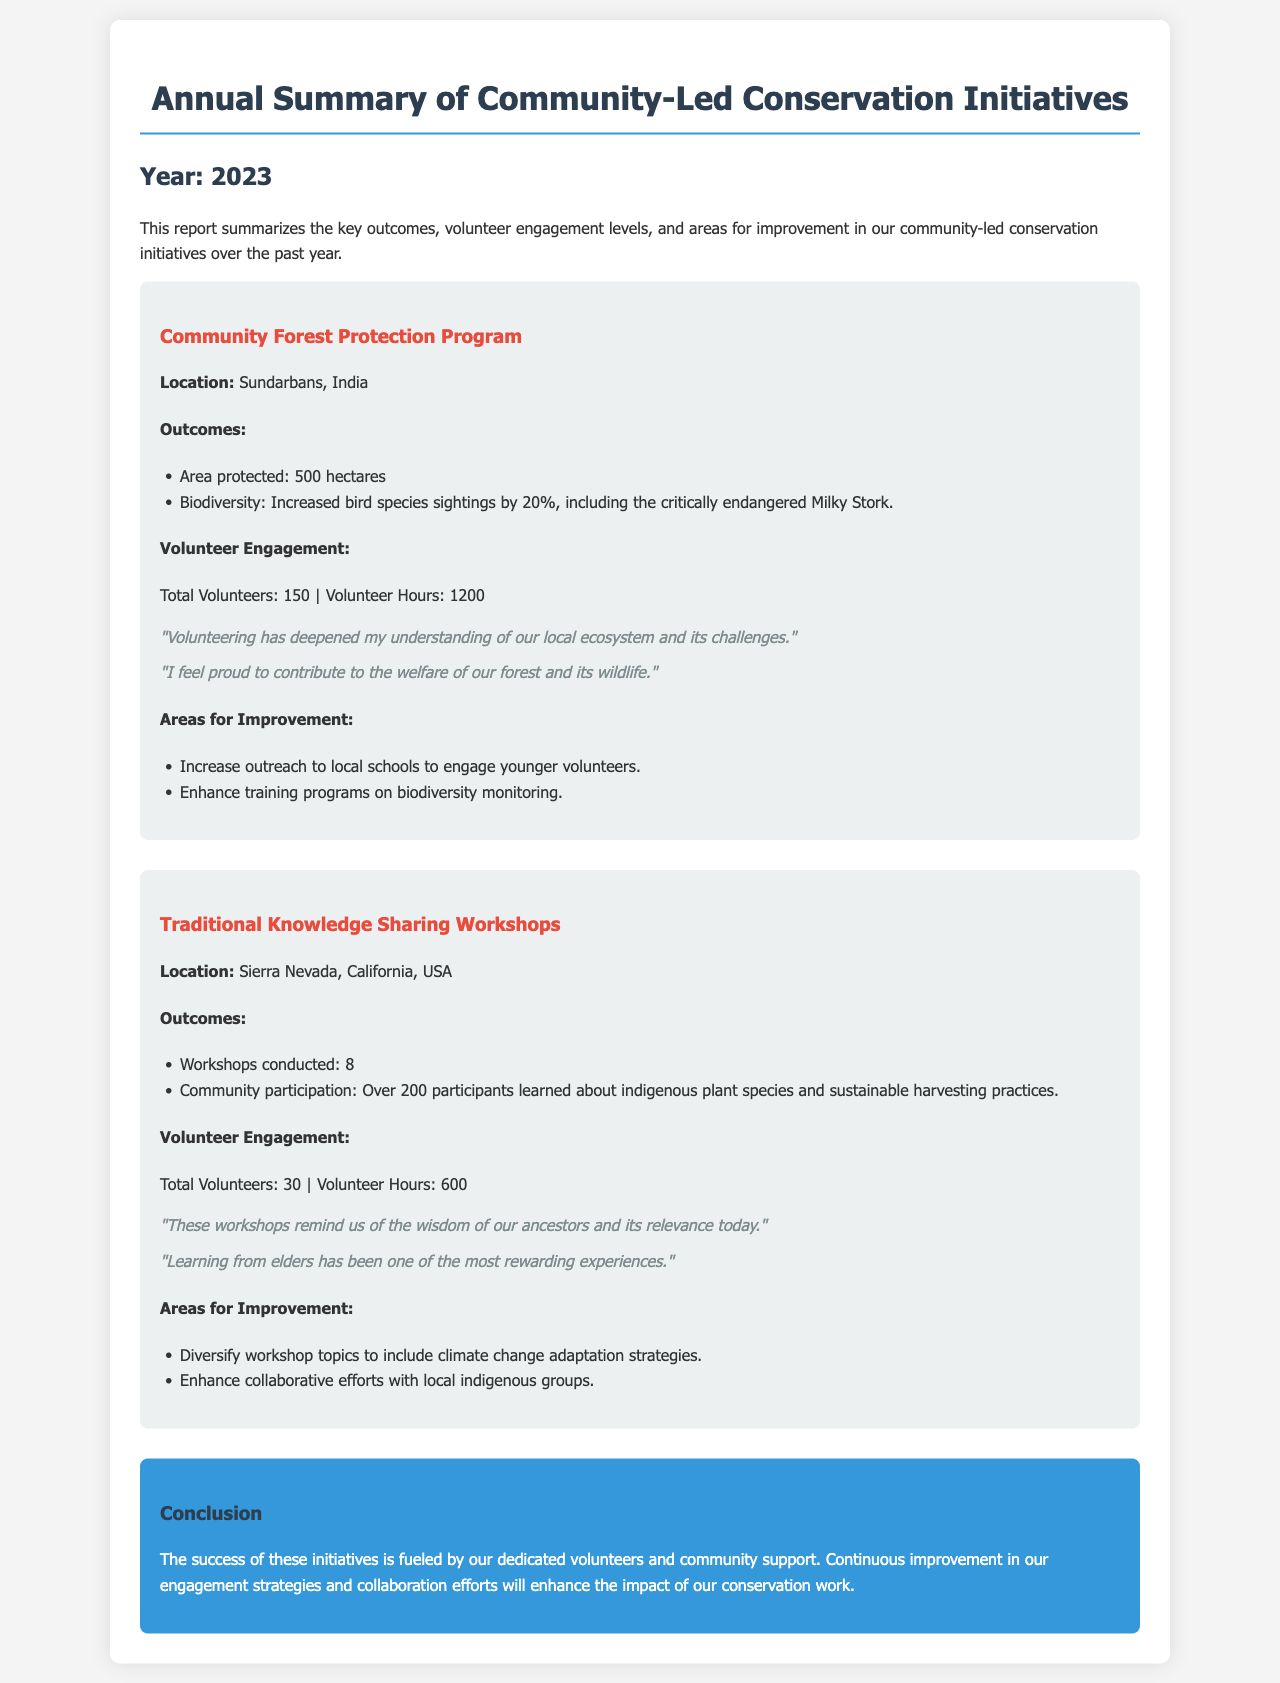What is the area protected by the Community Forest Protection Program? The area protected is listed as 500 hectares in the documentation.
Answer: 500 hectares How many bird species sightings increased in the Community Forest Protection Program? The increase in bird species sightings is noted as 20% in the report.
Answer: 20% How many workshops were conducted in the Traditional Knowledge Sharing Workshops? The document specifies that 8 workshops were conducted in total.
Answer: 8 What was the total number of volunteers for the Community Forest Protection Program? The total number of volunteers engaged in this program is stated as 150.
Answer: 150 What is one area for improvement mentioned for the Traditional Knowledge Sharing Workshops? The report lists diversifying workshop topics as an area for improvement.
Answer: Diversify workshop topics What inspires volunteers in the Community Forest Protection Program? A testimonial mentions that volunteering deepens understanding of the local ecosystem.
Answer: Understanding local ecosystem What is the total number of participants in the Traditional Knowledge Sharing Workshops? The document mentions that over 200 participants attended these workshops.
Answer: Over 200 participants What was the total volunteer hours for the Traditional Knowledge Sharing Workshops? The report specifies that a total of 600 volunteer hours were logged for these workshops.
Answer: 600 What does the conclusion highlight as essential for the success of the initiatives? The conclusion emphasizes that dedicated volunteers and community support are essential.
Answer: Dedicated volunteers and community support 